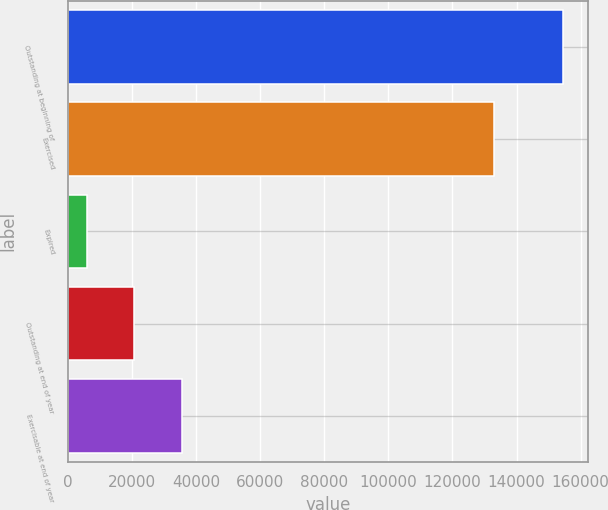Convert chart to OTSL. <chart><loc_0><loc_0><loc_500><loc_500><bar_chart><fcel>Outstanding at beginning of<fcel>Exercised<fcel>Expired<fcel>Outstanding at end of year<fcel>Exercisable at end of year<nl><fcel>154551<fcel>132905<fcel>5941<fcel>20802<fcel>35663<nl></chart> 